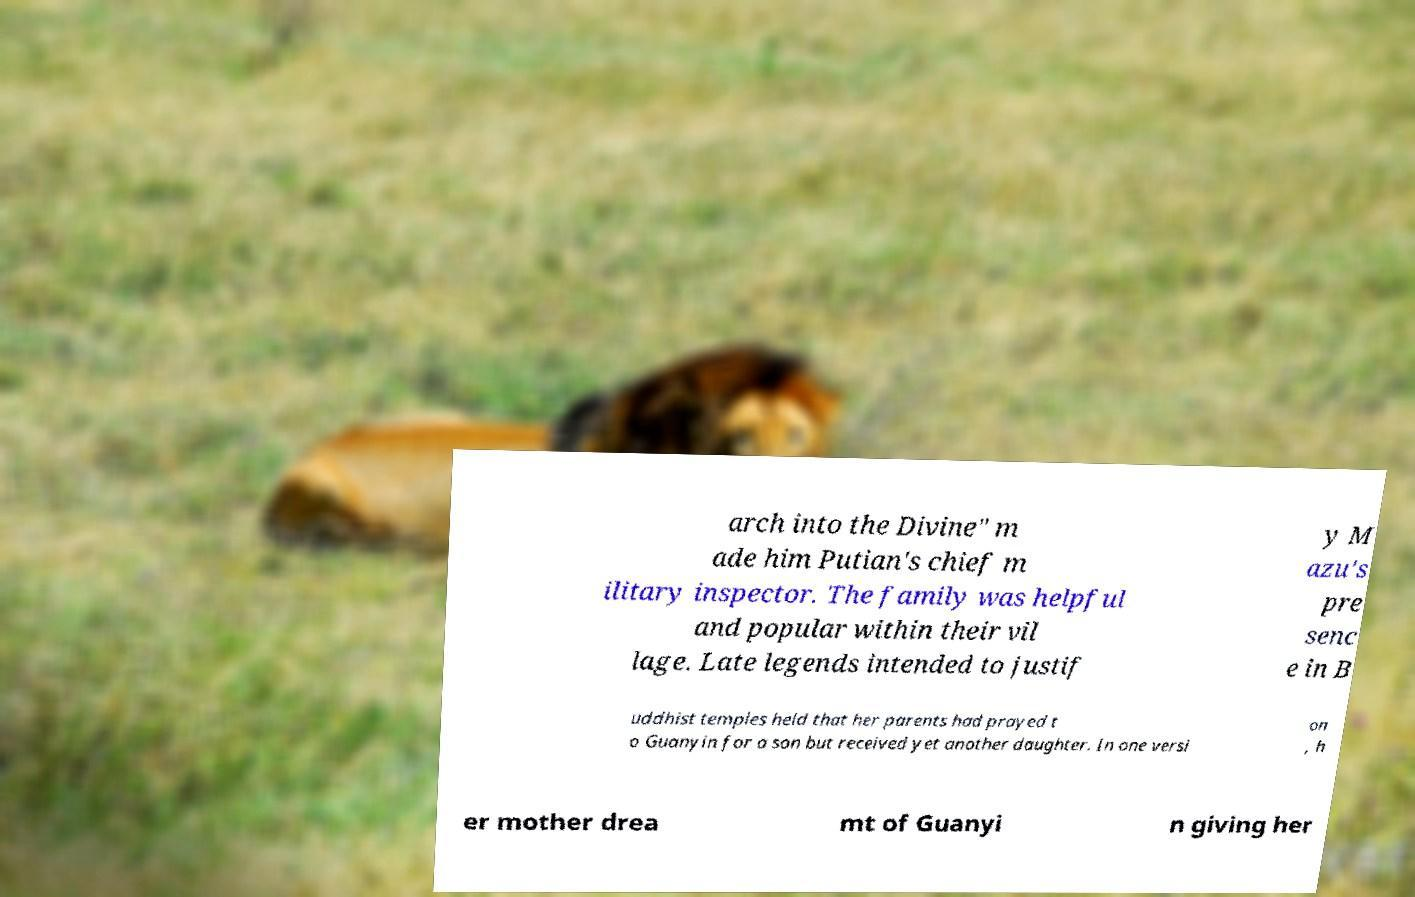There's text embedded in this image that I need extracted. Can you transcribe it verbatim? arch into the Divine" m ade him Putian's chief m ilitary inspector. The family was helpful and popular within their vil lage. Late legends intended to justif y M azu's pre senc e in B uddhist temples held that her parents had prayed t o Guanyin for a son but received yet another daughter. In one versi on , h er mother drea mt of Guanyi n giving her 